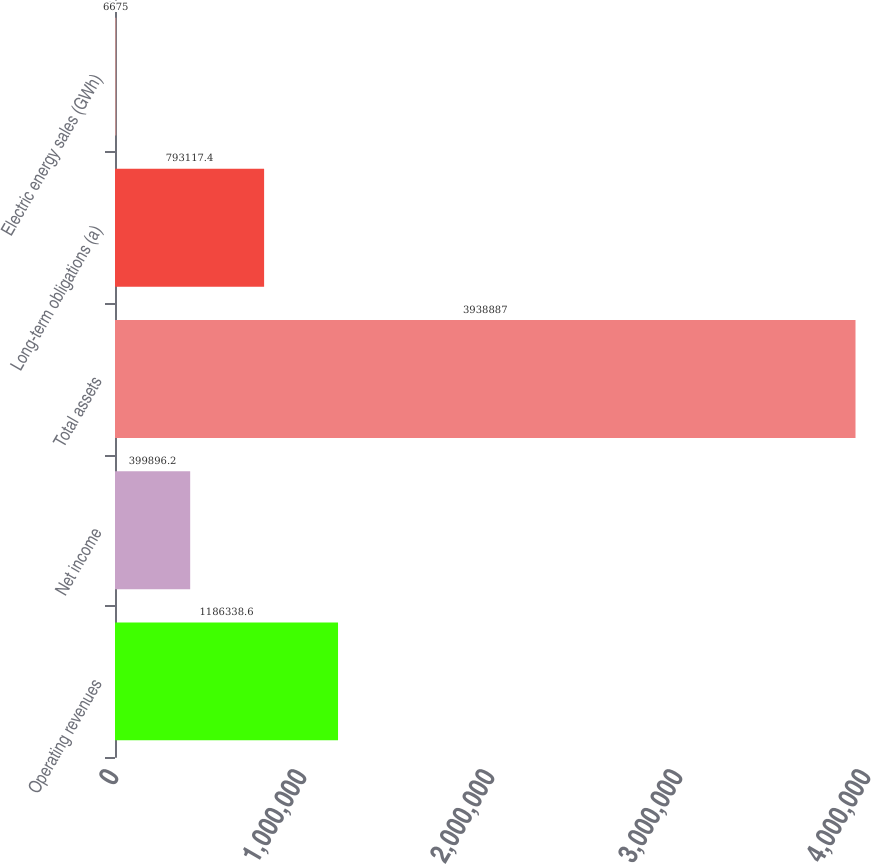<chart> <loc_0><loc_0><loc_500><loc_500><bar_chart><fcel>Operating revenues<fcel>Net income<fcel>Total assets<fcel>Long-term obligations (a)<fcel>Electric energy sales (GWh)<nl><fcel>1.18634e+06<fcel>399896<fcel>3.93889e+06<fcel>793117<fcel>6675<nl></chart> 